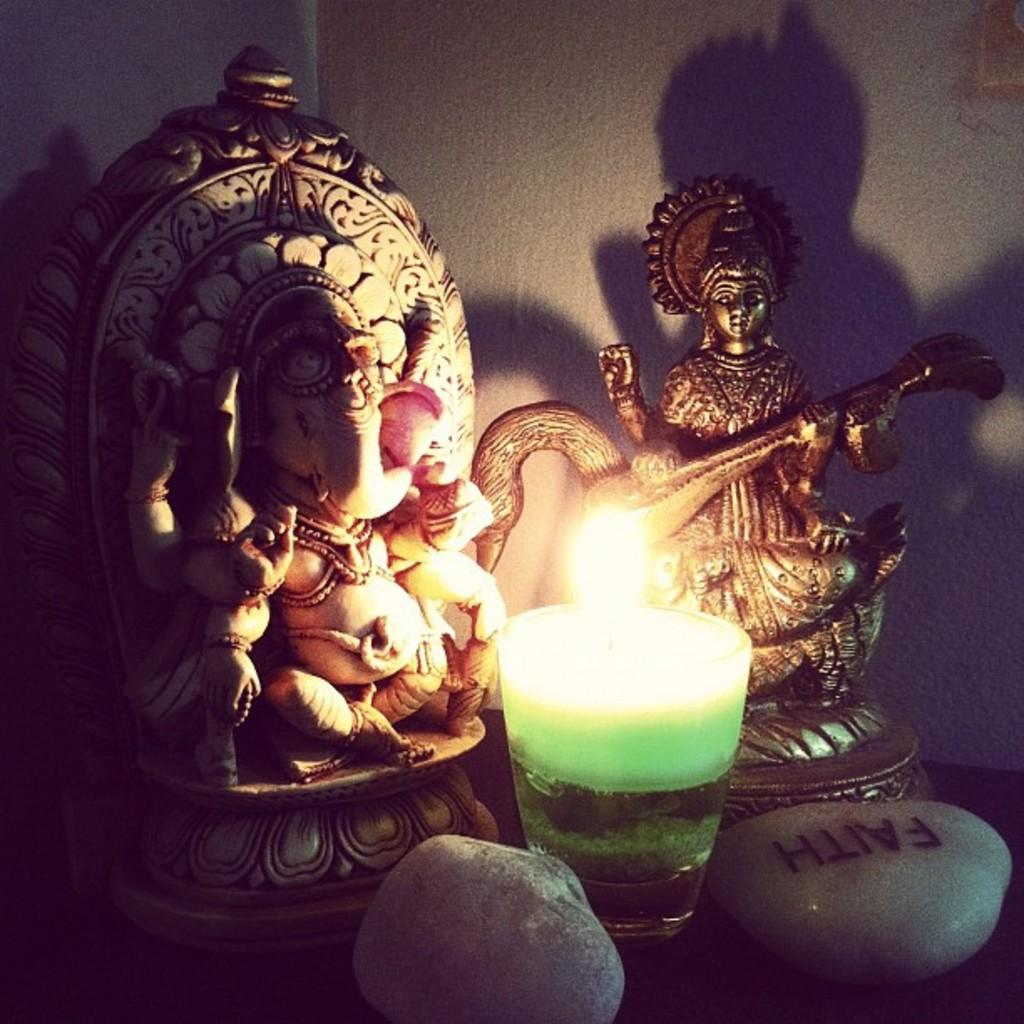What type of artwork can be seen in the image? There are sculptures in the image. What material is used for the sculptures? The stones in the image suggest that the sculptures are made of stone. Is there any source of light visible in the image? Yes, there is a candle in the image. What can be seen in the background of the image? There is a wall in the background of the image. How many cabbages are placed on top of the sculptures in the image? There are no cabbages present in the image; it features sculptures made of stone. Can you tell me how many times the person in the image sneezes? There is no person present in the image, so it is not possible to determine how many times they sneeze. 